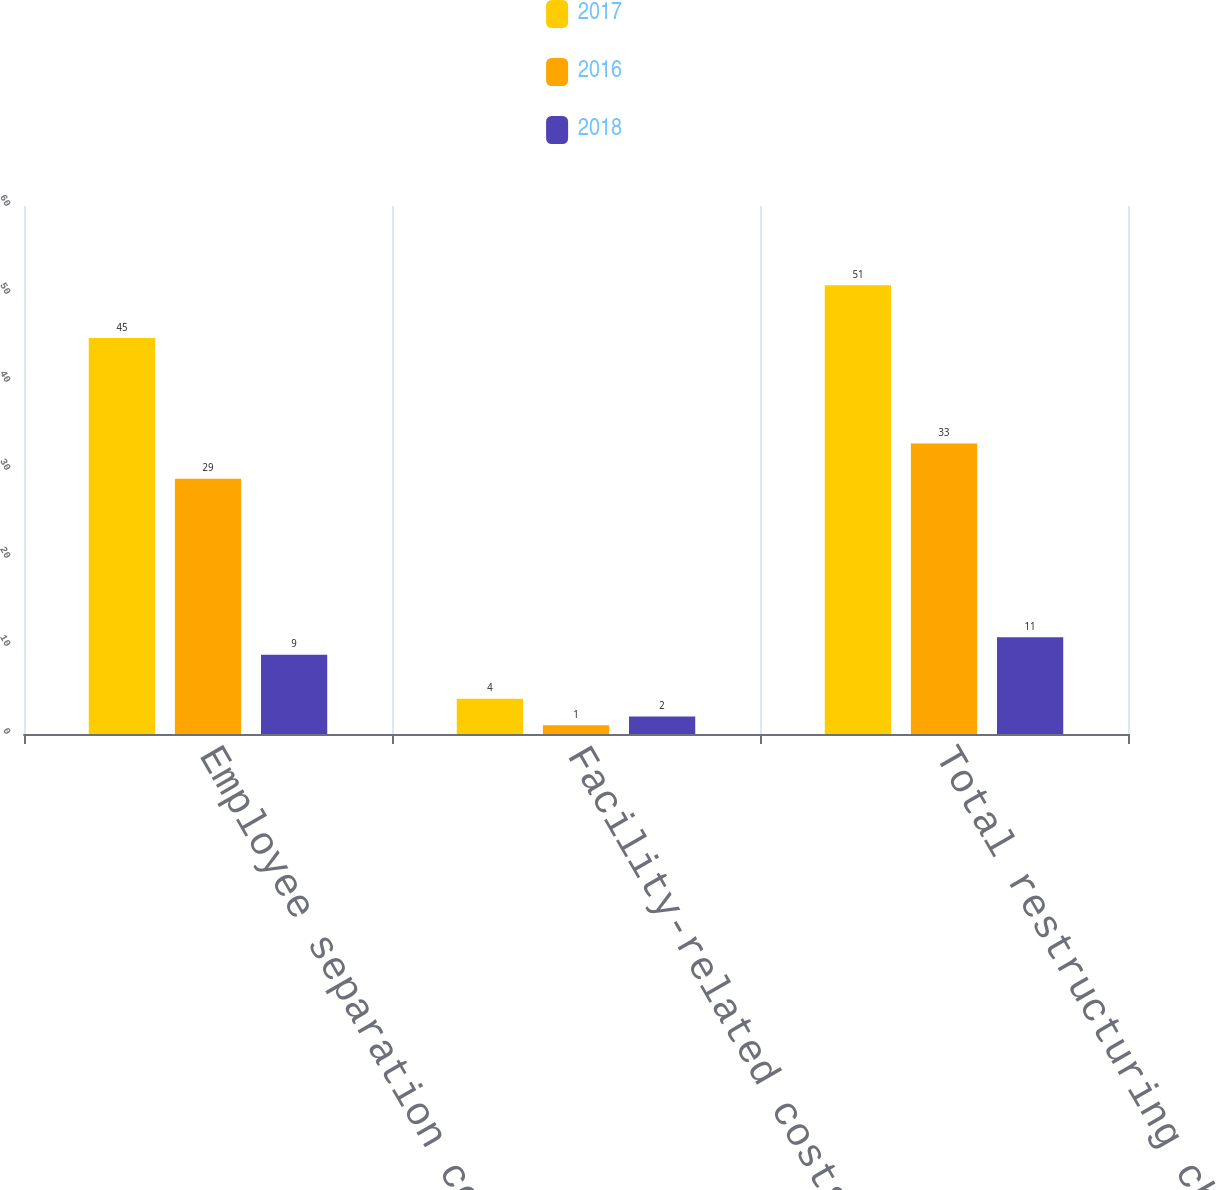<chart> <loc_0><loc_0><loc_500><loc_500><stacked_bar_chart><ecel><fcel>Employee separation costs<fcel>Facility-related costs<fcel>Total restructuring charges<nl><fcel>2017<fcel>45<fcel>4<fcel>51<nl><fcel>2016<fcel>29<fcel>1<fcel>33<nl><fcel>2018<fcel>9<fcel>2<fcel>11<nl></chart> 